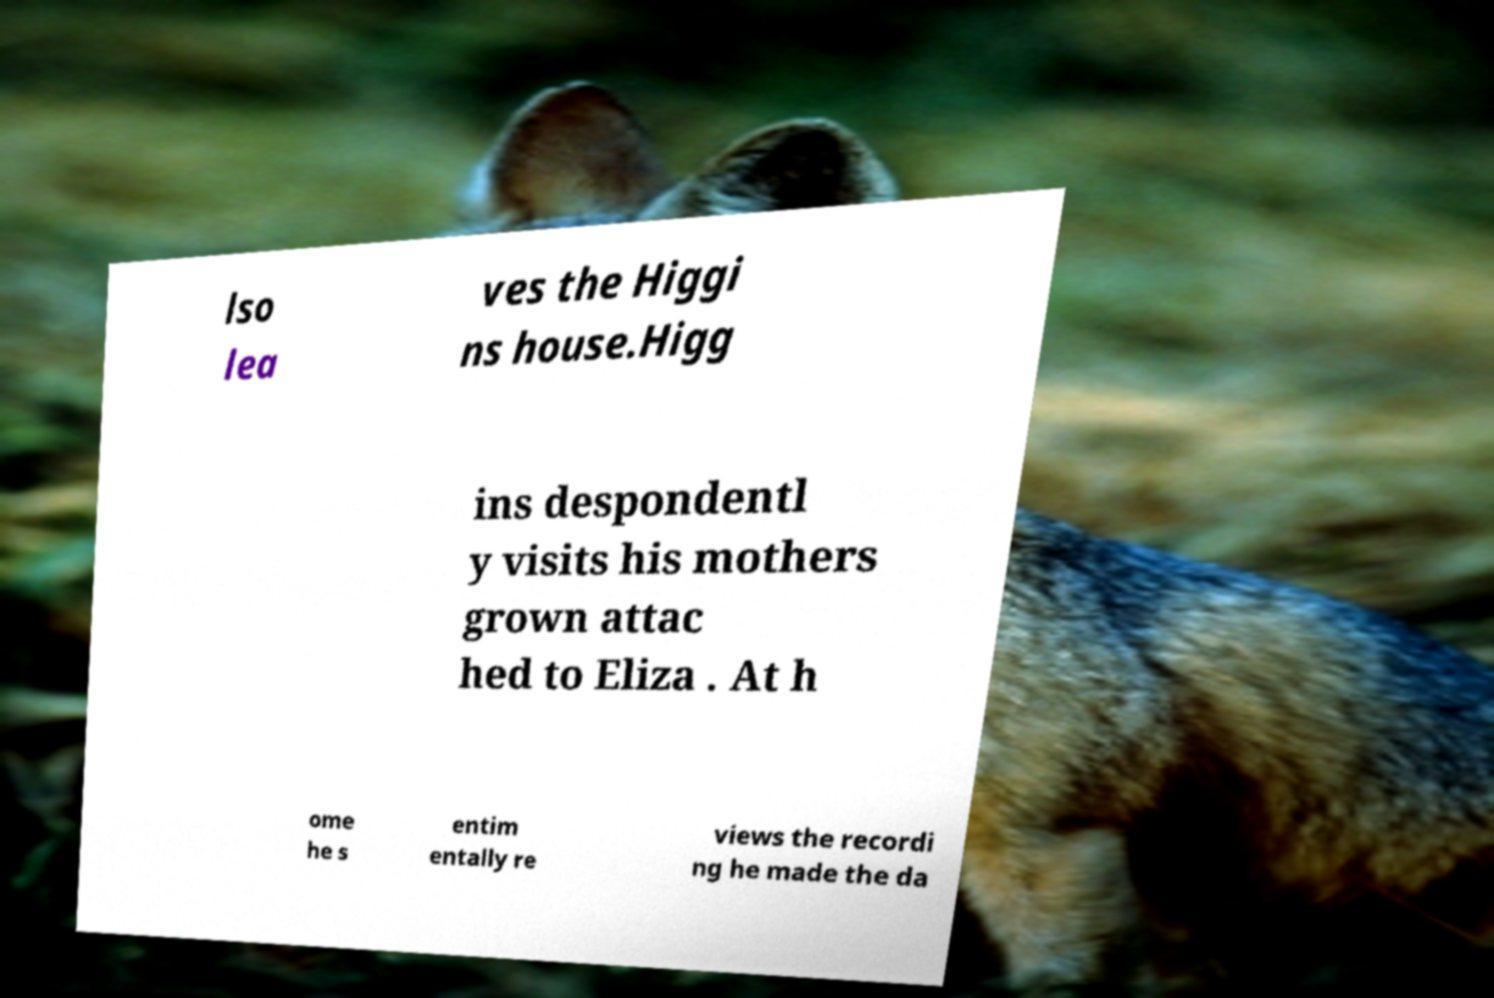There's text embedded in this image that I need extracted. Can you transcribe it verbatim? lso lea ves the Higgi ns house.Higg ins despondentl y visits his mothers grown attac hed to Eliza . At h ome he s entim entally re views the recordi ng he made the da 